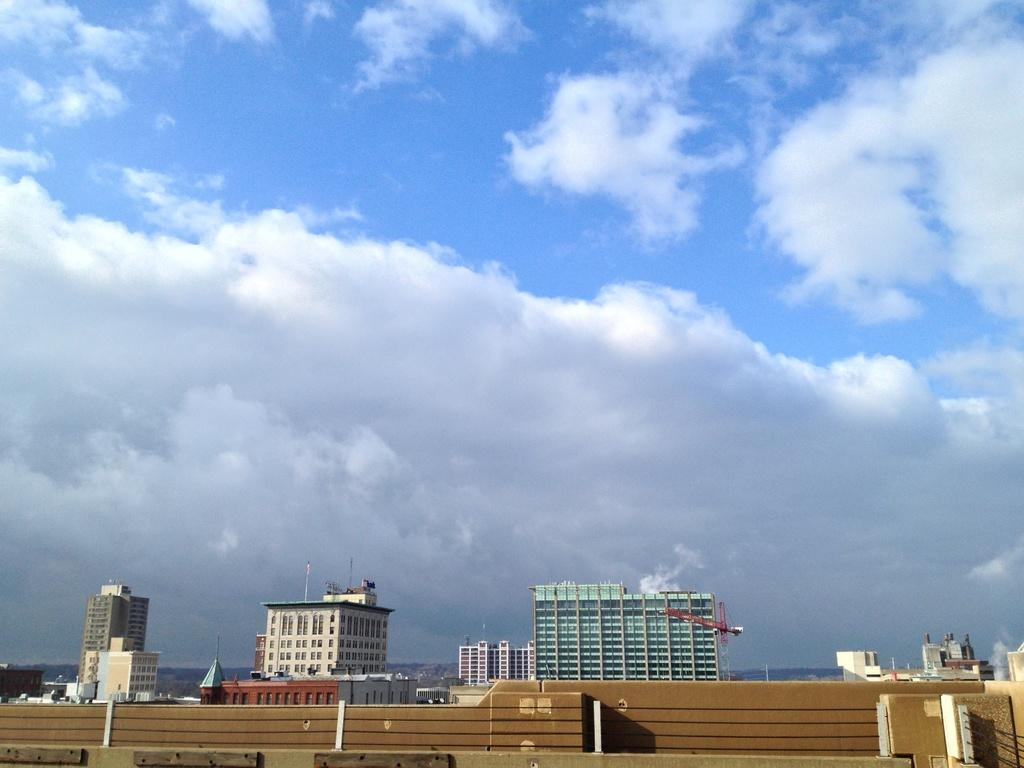What is located at the bottom of the image? There is a wall at the bottom of the image. What can be seen on the right side of the image? There is a fence on the right side of the image. What type of structures are visible in the background of the image? There are buildings, a crane, poles, and windows visible in the background of the image. What architectural features are present in the background of the image? Glass doors and a roof are present in the background of the image. What is visible in the sky in the background of the image? Clouds are present in the sky in the background of the image. Can you see a ghost walking through the buildings in the image? There is no ghost present in the image. What type of pan is being used to cook on the roof in the image? There is no pan or cooking activity visible in the image. 